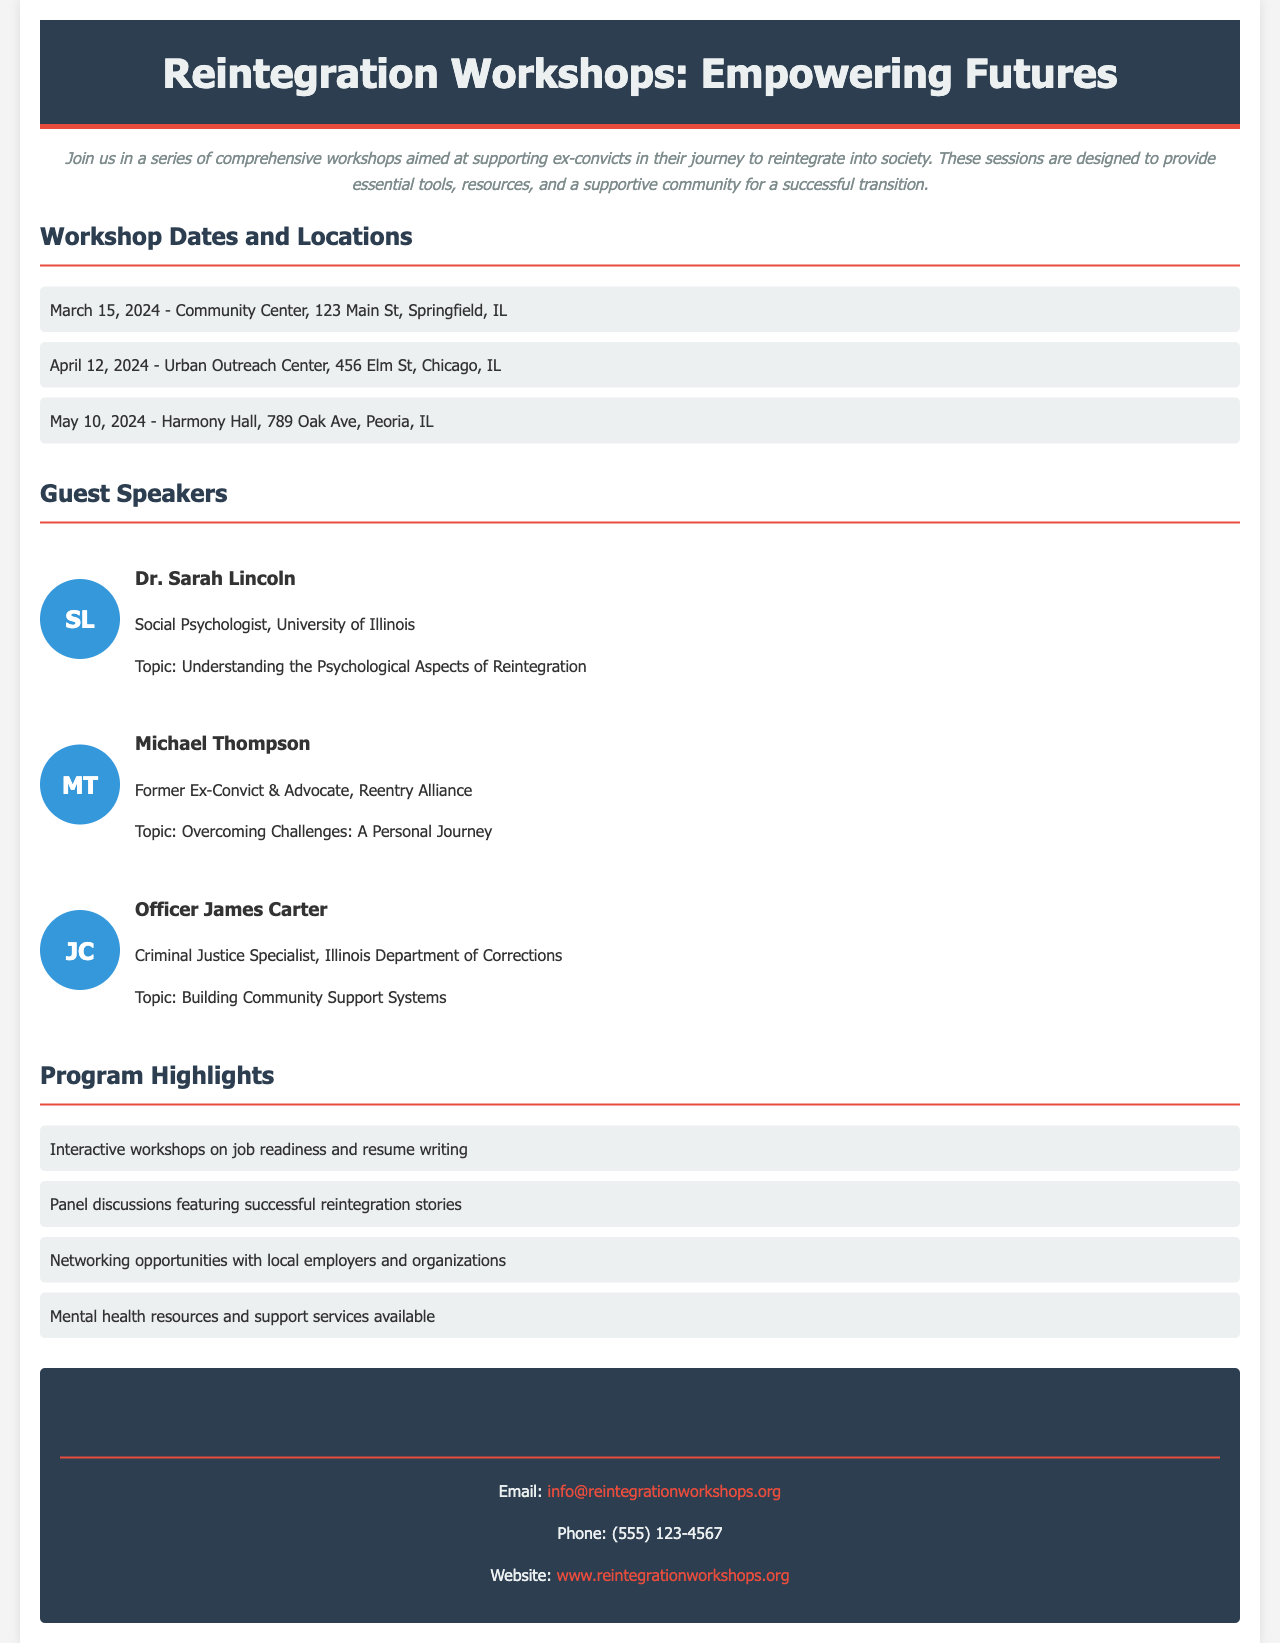What is the title of the workshop? The title of the workshop is presented in the header of the brochure.
Answer: Reintegration Workshops: Empowering Futures When is the first workshop scheduled? The first workshop date is listed under the Workshop Dates section.
Answer: March 15, 2024 Where will the second workshop take place? The location of the second workshop is specified in the Workshop Dates and Locations section.
Answer: Urban Outreach Center, 456 Elm St, Chicago, IL Who is one of the guest speakers? Guest speakers are highlighted in the Guest Speakers section, with names and roles.
Answer: Dr. Sarah Lincoln What is the topic of Officer James Carter's presentation? The topic is mentioned alongside his name in the Guest Speakers section.
Answer: Building Community Support Systems List one of the program highlights. Program highlights are summarized in a bullet list, detailing key aspects of the workshop.
Answer: Interactive workshops on job readiness and resume writing How many workshops are scheduled in total? The total number of workshops can be determined from the dates listed in the document.
Answer: Three What type of resources will be available at the workshops? The type of resources is mentioned in the Program Highlights section.
Answer: Mental health resources and support services available How can participants reach out for more information? Contact information provided includes email and phone details in the Contact Information section.
Answer: Email: info@reintegrationworkshops.org 